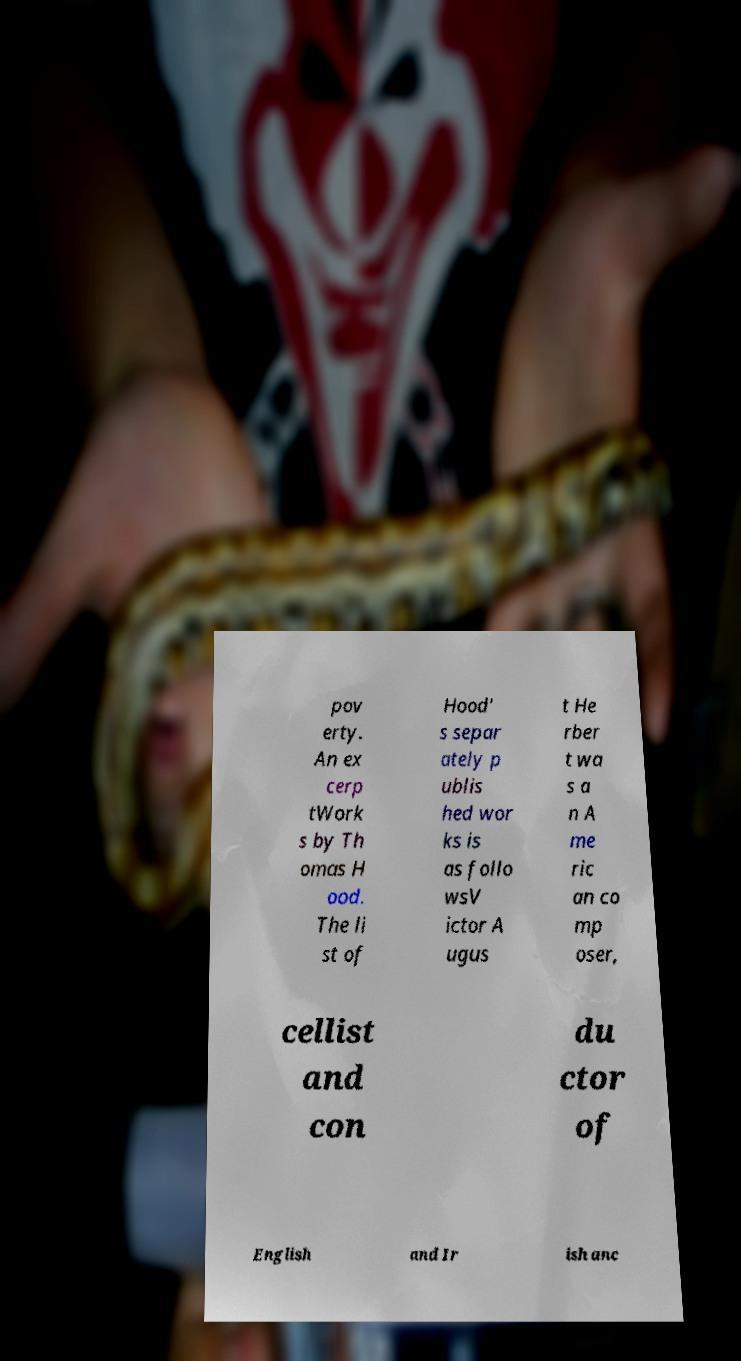What messages or text are displayed in this image? I need them in a readable, typed format. pov erty. An ex cerp tWork s by Th omas H ood. The li st of Hood' s separ ately p ublis hed wor ks is as follo wsV ictor A ugus t He rber t wa s a n A me ric an co mp oser, cellist and con du ctor of English and Ir ish anc 